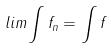<formula> <loc_0><loc_0><loc_500><loc_500>l i m \int f _ { n } = \int f</formula> 